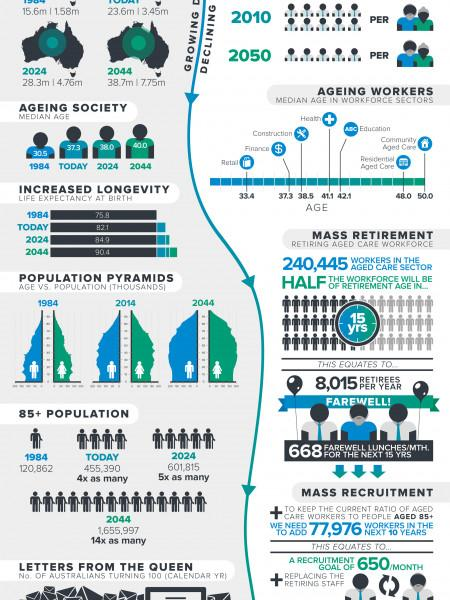Mention a couple of crucial points in this snapshot. The median age of health workers is 41.1 years old. In 2024, the life expectancy rate is projected to be the second-highest on record. The population of older people in the current year is 455,390. According to the current data, the life expectancy rate for the current year is 82.1. The highest median age of individuals working in any sector is in Community Aged Care, according to recent data. 